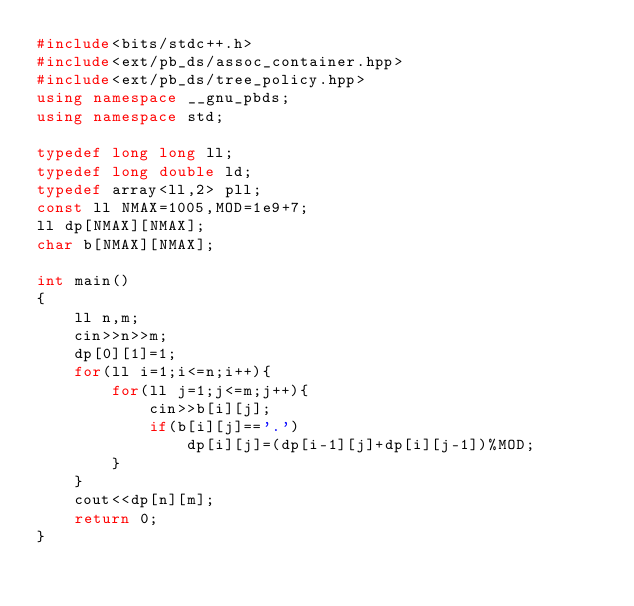<code> <loc_0><loc_0><loc_500><loc_500><_C++_>#include<bits/stdc++.h>
#include<ext/pb_ds/assoc_container.hpp>
#include<ext/pb_ds/tree_policy.hpp>
using namespace __gnu_pbds;
using namespace std;

typedef long long ll;
typedef long double ld;
typedef array<ll,2> pll;
const ll NMAX=1005,MOD=1e9+7;
ll dp[NMAX][NMAX];
char b[NMAX][NMAX];

int main()
{
    ll n,m;
    cin>>n>>m;
    dp[0][1]=1;
    for(ll i=1;i<=n;i++){
        for(ll j=1;j<=m;j++){
            cin>>b[i][j];
            if(b[i][j]=='.')
                dp[i][j]=(dp[i-1][j]+dp[i][j-1])%MOD;
        }
    }
    cout<<dp[n][m];
    return 0;
}
</code> 